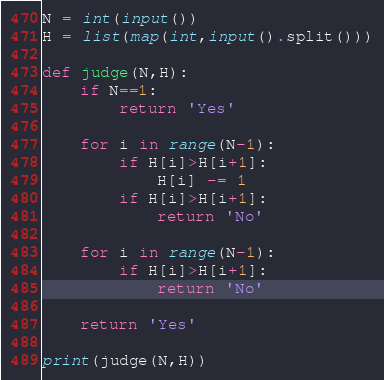Convert code to text. <code><loc_0><loc_0><loc_500><loc_500><_Python_>N = int(input())
H = list(map(int,input().split()))

def judge(N,H):
    if N==1:
        return 'Yes'

    for i in range(N-1):
        if H[i]>H[i+1]:
            H[i] -= 1
        if H[i]>H[i+1]:
            return 'No'
    
    for i in range(N-1):
        if H[i]>H[i+1]:
            return 'No'
    
    return 'Yes'

print(judge(N,H))</code> 